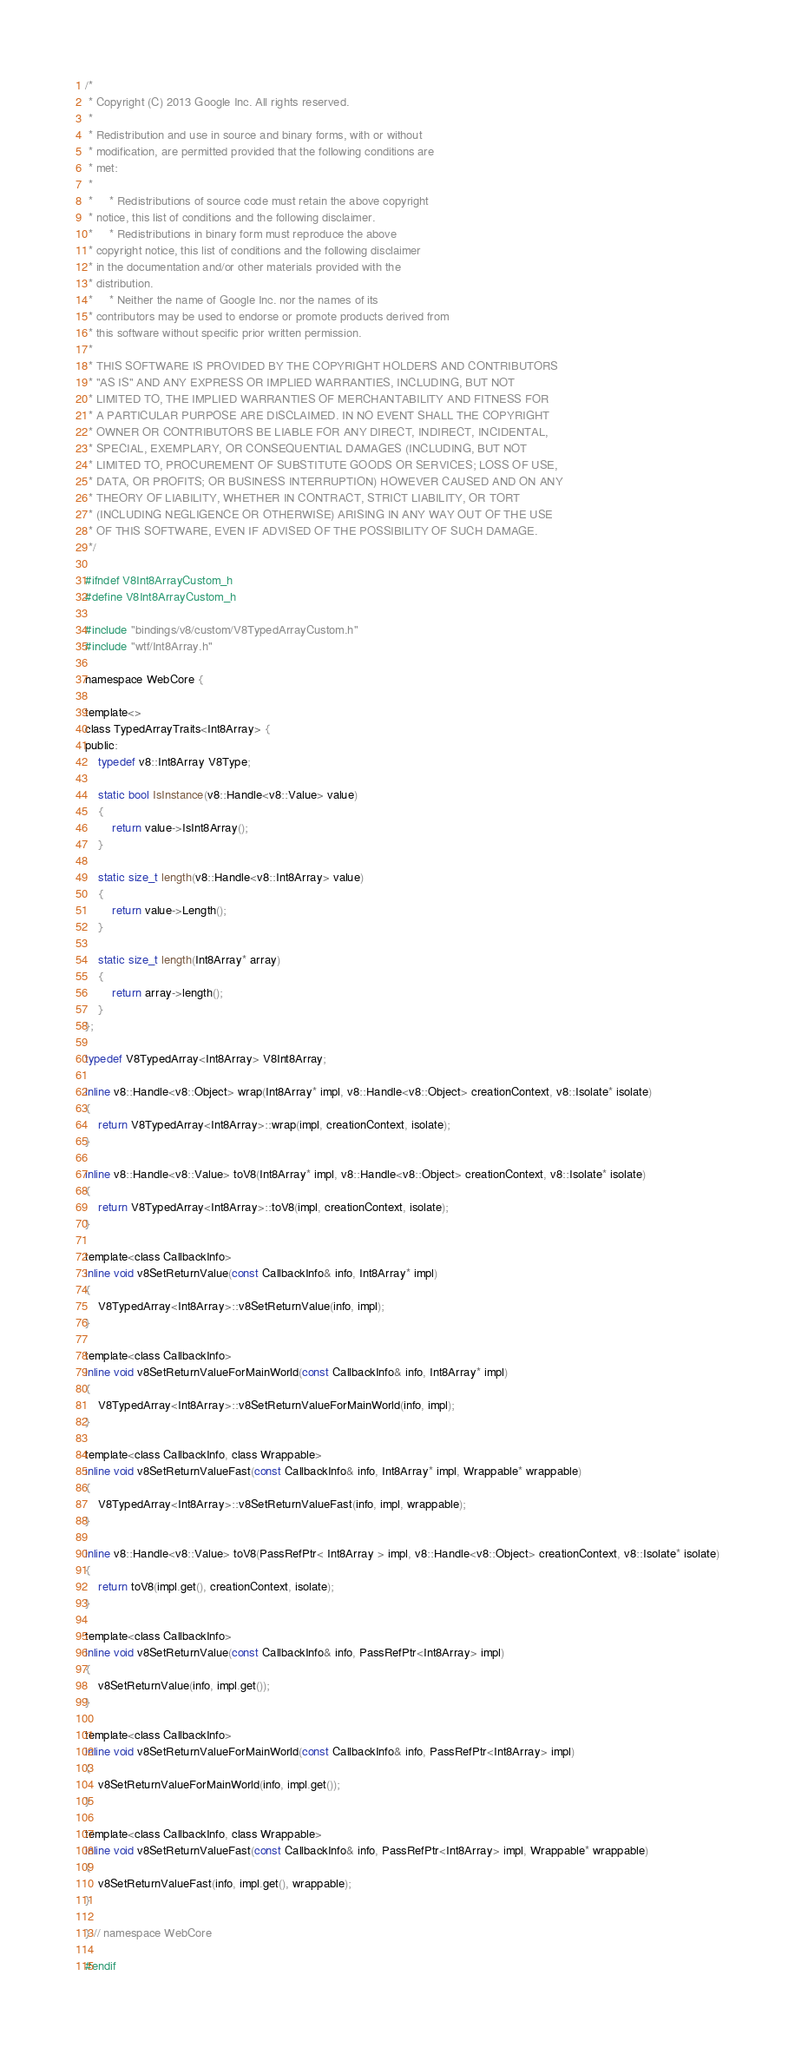Convert code to text. <code><loc_0><loc_0><loc_500><loc_500><_C_>/*
 * Copyright (C) 2013 Google Inc. All rights reserved.
 *
 * Redistribution and use in source and binary forms, with or without
 * modification, are permitted provided that the following conditions are
 * met:
 *
 *     * Redistributions of source code must retain the above copyright
 * notice, this list of conditions and the following disclaimer.
 *     * Redistributions in binary form must reproduce the above
 * copyright notice, this list of conditions and the following disclaimer
 * in the documentation and/or other materials provided with the
 * distribution.
 *     * Neither the name of Google Inc. nor the names of its
 * contributors may be used to endorse or promote products derived from
 * this software without specific prior written permission.
 *
 * THIS SOFTWARE IS PROVIDED BY THE COPYRIGHT HOLDERS AND CONTRIBUTORS
 * "AS IS" AND ANY EXPRESS OR IMPLIED WARRANTIES, INCLUDING, BUT NOT
 * LIMITED TO, THE IMPLIED WARRANTIES OF MERCHANTABILITY AND FITNESS FOR
 * A PARTICULAR PURPOSE ARE DISCLAIMED. IN NO EVENT SHALL THE COPYRIGHT
 * OWNER OR CONTRIBUTORS BE LIABLE FOR ANY DIRECT, INDIRECT, INCIDENTAL,
 * SPECIAL, EXEMPLARY, OR CONSEQUENTIAL DAMAGES (INCLUDING, BUT NOT
 * LIMITED TO, PROCUREMENT OF SUBSTITUTE GOODS OR SERVICES; LOSS OF USE,
 * DATA, OR PROFITS; OR BUSINESS INTERRUPTION) HOWEVER CAUSED AND ON ANY
 * THEORY OF LIABILITY, WHETHER IN CONTRACT, STRICT LIABILITY, OR TORT
 * (INCLUDING NEGLIGENCE OR OTHERWISE) ARISING IN ANY WAY OUT OF THE USE
 * OF THIS SOFTWARE, EVEN IF ADVISED OF THE POSSIBILITY OF SUCH DAMAGE.
 */

#ifndef V8Int8ArrayCustom_h
#define V8Int8ArrayCustom_h

#include "bindings/v8/custom/V8TypedArrayCustom.h"
#include "wtf/Int8Array.h"

namespace WebCore {

template<>
class TypedArrayTraits<Int8Array> {
public:
    typedef v8::Int8Array V8Type;

    static bool IsInstance(v8::Handle<v8::Value> value)
    {
        return value->IsInt8Array();
    }

    static size_t length(v8::Handle<v8::Int8Array> value)
    {
        return value->Length();
    }

    static size_t length(Int8Array* array)
    {
        return array->length();
    }
};

typedef V8TypedArray<Int8Array> V8Int8Array;

inline v8::Handle<v8::Object> wrap(Int8Array* impl, v8::Handle<v8::Object> creationContext, v8::Isolate* isolate)
{
    return V8TypedArray<Int8Array>::wrap(impl, creationContext, isolate);
}

inline v8::Handle<v8::Value> toV8(Int8Array* impl, v8::Handle<v8::Object> creationContext, v8::Isolate* isolate)
{
    return V8TypedArray<Int8Array>::toV8(impl, creationContext, isolate);
}

template<class CallbackInfo>
inline void v8SetReturnValue(const CallbackInfo& info, Int8Array* impl)
{
    V8TypedArray<Int8Array>::v8SetReturnValue(info, impl);
}

template<class CallbackInfo>
inline void v8SetReturnValueForMainWorld(const CallbackInfo& info, Int8Array* impl)
{
    V8TypedArray<Int8Array>::v8SetReturnValueForMainWorld(info, impl);
}

template<class CallbackInfo, class Wrappable>
inline void v8SetReturnValueFast(const CallbackInfo& info, Int8Array* impl, Wrappable* wrappable)
{
    V8TypedArray<Int8Array>::v8SetReturnValueFast(info, impl, wrappable);
}

inline v8::Handle<v8::Value> toV8(PassRefPtr< Int8Array > impl, v8::Handle<v8::Object> creationContext, v8::Isolate* isolate)
{
    return toV8(impl.get(), creationContext, isolate);
}

template<class CallbackInfo>
inline void v8SetReturnValue(const CallbackInfo& info, PassRefPtr<Int8Array> impl)
{
    v8SetReturnValue(info, impl.get());
}

template<class CallbackInfo>
inline void v8SetReturnValueForMainWorld(const CallbackInfo& info, PassRefPtr<Int8Array> impl)
{
    v8SetReturnValueForMainWorld(info, impl.get());
}

template<class CallbackInfo, class Wrappable>
inline void v8SetReturnValueFast(const CallbackInfo& info, PassRefPtr<Int8Array> impl, Wrappable* wrappable)
{
    v8SetReturnValueFast(info, impl.get(), wrappable);
}

} // namespace WebCore

#endif
</code> 